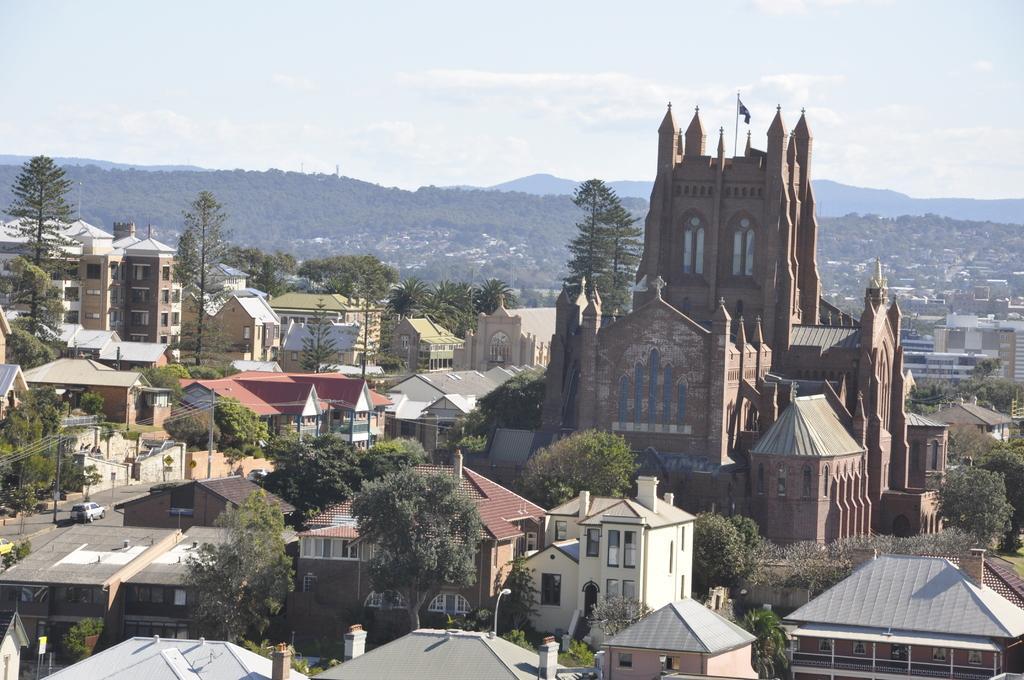Please provide a concise description of this image. This is an aerial view image of a city, there is a castle on the right side with buildings all around it with plants in front of it, in the back there are hills covered with trees and above its sky with clouds. 